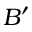Convert formula to latex. <formula><loc_0><loc_0><loc_500><loc_500>B ^ { \prime }</formula> 